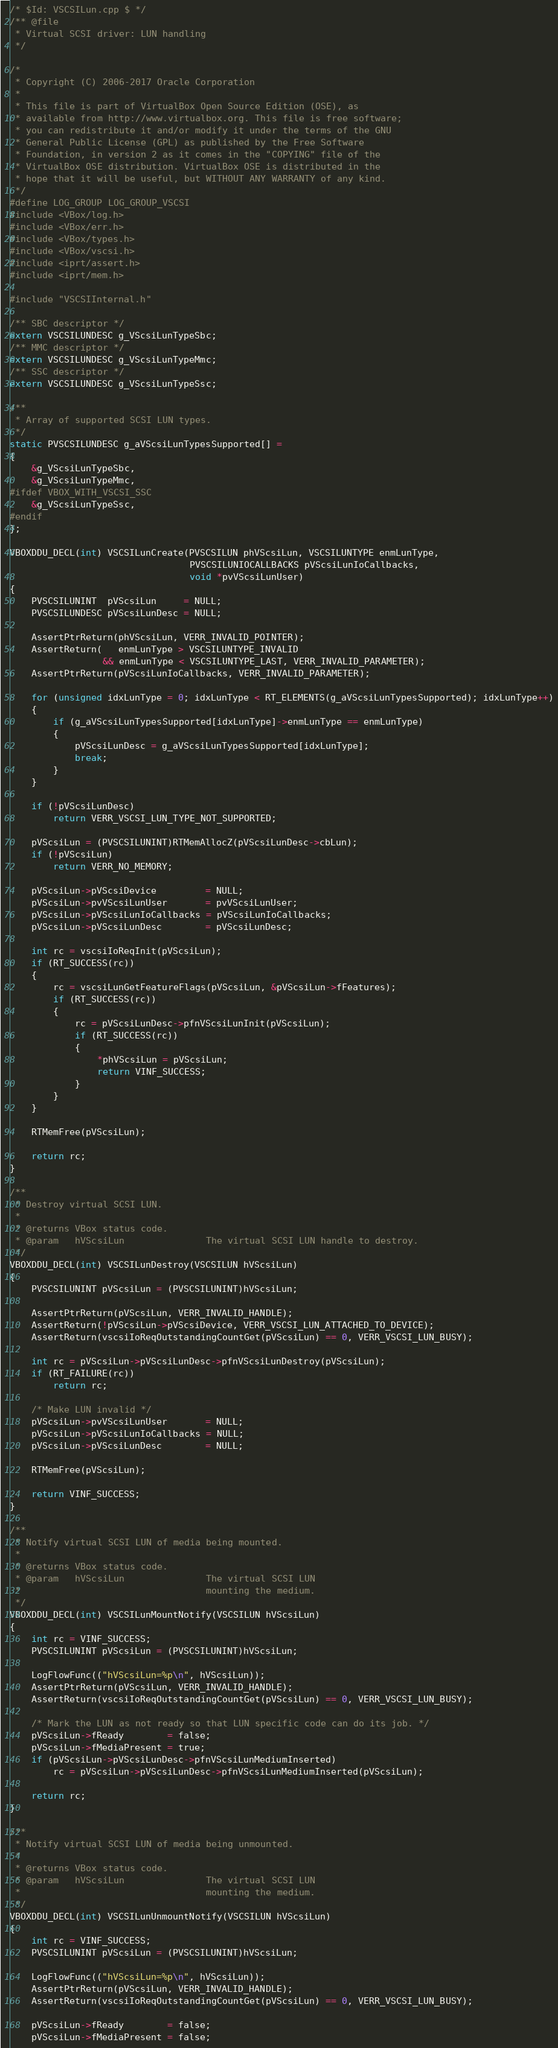Convert code to text. <code><loc_0><loc_0><loc_500><loc_500><_C++_>/* $Id: VSCSILun.cpp $ */
/** @file
 * Virtual SCSI driver: LUN handling
 */

/*
 * Copyright (C) 2006-2017 Oracle Corporation
 *
 * This file is part of VirtualBox Open Source Edition (OSE), as
 * available from http://www.virtualbox.org. This file is free software;
 * you can redistribute it and/or modify it under the terms of the GNU
 * General Public License (GPL) as published by the Free Software
 * Foundation, in version 2 as it comes in the "COPYING" file of the
 * VirtualBox OSE distribution. VirtualBox OSE is distributed in the
 * hope that it will be useful, but WITHOUT ANY WARRANTY of any kind.
 */
#define LOG_GROUP LOG_GROUP_VSCSI
#include <VBox/log.h>
#include <VBox/err.h>
#include <VBox/types.h>
#include <VBox/vscsi.h>
#include <iprt/assert.h>
#include <iprt/mem.h>

#include "VSCSIInternal.h"

/** SBC descriptor */
extern VSCSILUNDESC g_VScsiLunTypeSbc;
/** MMC descriptor */
extern VSCSILUNDESC g_VScsiLunTypeMmc;
/** SSC descriptor */
extern VSCSILUNDESC g_VScsiLunTypeSsc;

/**
 * Array of supported SCSI LUN types.
 */
static PVSCSILUNDESC g_aVScsiLunTypesSupported[] =
{
    &g_VScsiLunTypeSbc,
    &g_VScsiLunTypeMmc,
#ifdef VBOX_WITH_VSCSI_SSC
    &g_VScsiLunTypeSsc,
#endif
};

VBOXDDU_DECL(int) VSCSILunCreate(PVSCSILUN phVScsiLun, VSCSILUNTYPE enmLunType,
                                 PVSCSILUNIOCALLBACKS pVScsiLunIoCallbacks,
                                 void *pvVScsiLunUser)
{
    PVSCSILUNINT  pVScsiLun     = NULL;
    PVSCSILUNDESC pVScsiLunDesc = NULL;

    AssertPtrReturn(phVScsiLun, VERR_INVALID_POINTER);
    AssertReturn(   enmLunType > VSCSILUNTYPE_INVALID
                 && enmLunType < VSCSILUNTYPE_LAST, VERR_INVALID_PARAMETER);
    AssertPtrReturn(pVScsiLunIoCallbacks, VERR_INVALID_PARAMETER);

    for (unsigned idxLunType = 0; idxLunType < RT_ELEMENTS(g_aVScsiLunTypesSupported); idxLunType++)
    {
        if (g_aVScsiLunTypesSupported[idxLunType]->enmLunType == enmLunType)
        {
            pVScsiLunDesc = g_aVScsiLunTypesSupported[idxLunType];
            break;
        }
    }

    if (!pVScsiLunDesc)
        return VERR_VSCSI_LUN_TYPE_NOT_SUPPORTED;

    pVScsiLun = (PVSCSILUNINT)RTMemAllocZ(pVScsiLunDesc->cbLun);
    if (!pVScsiLun)
        return VERR_NO_MEMORY;

    pVScsiLun->pVScsiDevice         = NULL;
    pVScsiLun->pvVScsiLunUser       = pvVScsiLunUser;
    pVScsiLun->pVScsiLunIoCallbacks = pVScsiLunIoCallbacks;
    pVScsiLun->pVScsiLunDesc        = pVScsiLunDesc;

    int rc = vscsiIoReqInit(pVScsiLun);
    if (RT_SUCCESS(rc))
    {
        rc = vscsiLunGetFeatureFlags(pVScsiLun, &pVScsiLun->fFeatures);
        if (RT_SUCCESS(rc))
        {
            rc = pVScsiLunDesc->pfnVScsiLunInit(pVScsiLun);
            if (RT_SUCCESS(rc))
            {
                *phVScsiLun = pVScsiLun;
                return VINF_SUCCESS;
            }
        }
    }

    RTMemFree(pVScsiLun);

    return rc;
}

/**
 * Destroy virtual SCSI LUN.
 *
 * @returns VBox status code.
 * @param   hVScsiLun               The virtual SCSI LUN handle to destroy.
 */
VBOXDDU_DECL(int) VSCSILunDestroy(VSCSILUN hVScsiLun)
{
    PVSCSILUNINT pVScsiLun = (PVSCSILUNINT)hVScsiLun;

    AssertPtrReturn(pVScsiLun, VERR_INVALID_HANDLE);
    AssertReturn(!pVScsiLun->pVScsiDevice, VERR_VSCSI_LUN_ATTACHED_TO_DEVICE);
    AssertReturn(vscsiIoReqOutstandingCountGet(pVScsiLun) == 0, VERR_VSCSI_LUN_BUSY);

    int rc = pVScsiLun->pVScsiLunDesc->pfnVScsiLunDestroy(pVScsiLun);
    if (RT_FAILURE(rc))
        return rc;

    /* Make LUN invalid */
    pVScsiLun->pvVScsiLunUser       = NULL;
    pVScsiLun->pVScsiLunIoCallbacks = NULL;
    pVScsiLun->pVScsiLunDesc        = NULL;

    RTMemFree(pVScsiLun);

    return VINF_SUCCESS;
}

/**
 * Notify virtual SCSI LUN of media being mounted.
 *
 * @returns VBox status code.
 * @param   hVScsiLun               The virtual SCSI LUN
 *                                  mounting the medium.
 */
VBOXDDU_DECL(int) VSCSILunMountNotify(VSCSILUN hVScsiLun)
{
    int rc = VINF_SUCCESS;
    PVSCSILUNINT pVScsiLun = (PVSCSILUNINT)hVScsiLun;

    LogFlowFunc(("hVScsiLun=%p\n", hVScsiLun));
    AssertPtrReturn(pVScsiLun, VERR_INVALID_HANDLE);
    AssertReturn(vscsiIoReqOutstandingCountGet(pVScsiLun) == 0, VERR_VSCSI_LUN_BUSY);

    /* Mark the LUN as not ready so that LUN specific code can do its job. */
    pVScsiLun->fReady        = false;
    pVScsiLun->fMediaPresent = true;
    if (pVScsiLun->pVScsiLunDesc->pfnVScsiLunMediumInserted)
        rc = pVScsiLun->pVScsiLunDesc->pfnVScsiLunMediumInserted(pVScsiLun);

    return rc;
}

/**
 * Notify virtual SCSI LUN of media being unmounted.
 *
 * @returns VBox status code.
 * @param   hVScsiLun               The virtual SCSI LUN
 *                                  mounting the medium.
 */
VBOXDDU_DECL(int) VSCSILunUnmountNotify(VSCSILUN hVScsiLun)
{
    int rc = VINF_SUCCESS;
    PVSCSILUNINT pVScsiLun = (PVSCSILUNINT)hVScsiLun;

    LogFlowFunc(("hVScsiLun=%p\n", hVScsiLun));
    AssertPtrReturn(pVScsiLun, VERR_INVALID_HANDLE);
    AssertReturn(vscsiIoReqOutstandingCountGet(pVScsiLun) == 0, VERR_VSCSI_LUN_BUSY);

    pVScsiLun->fReady        = false;
    pVScsiLun->fMediaPresent = false;</code> 